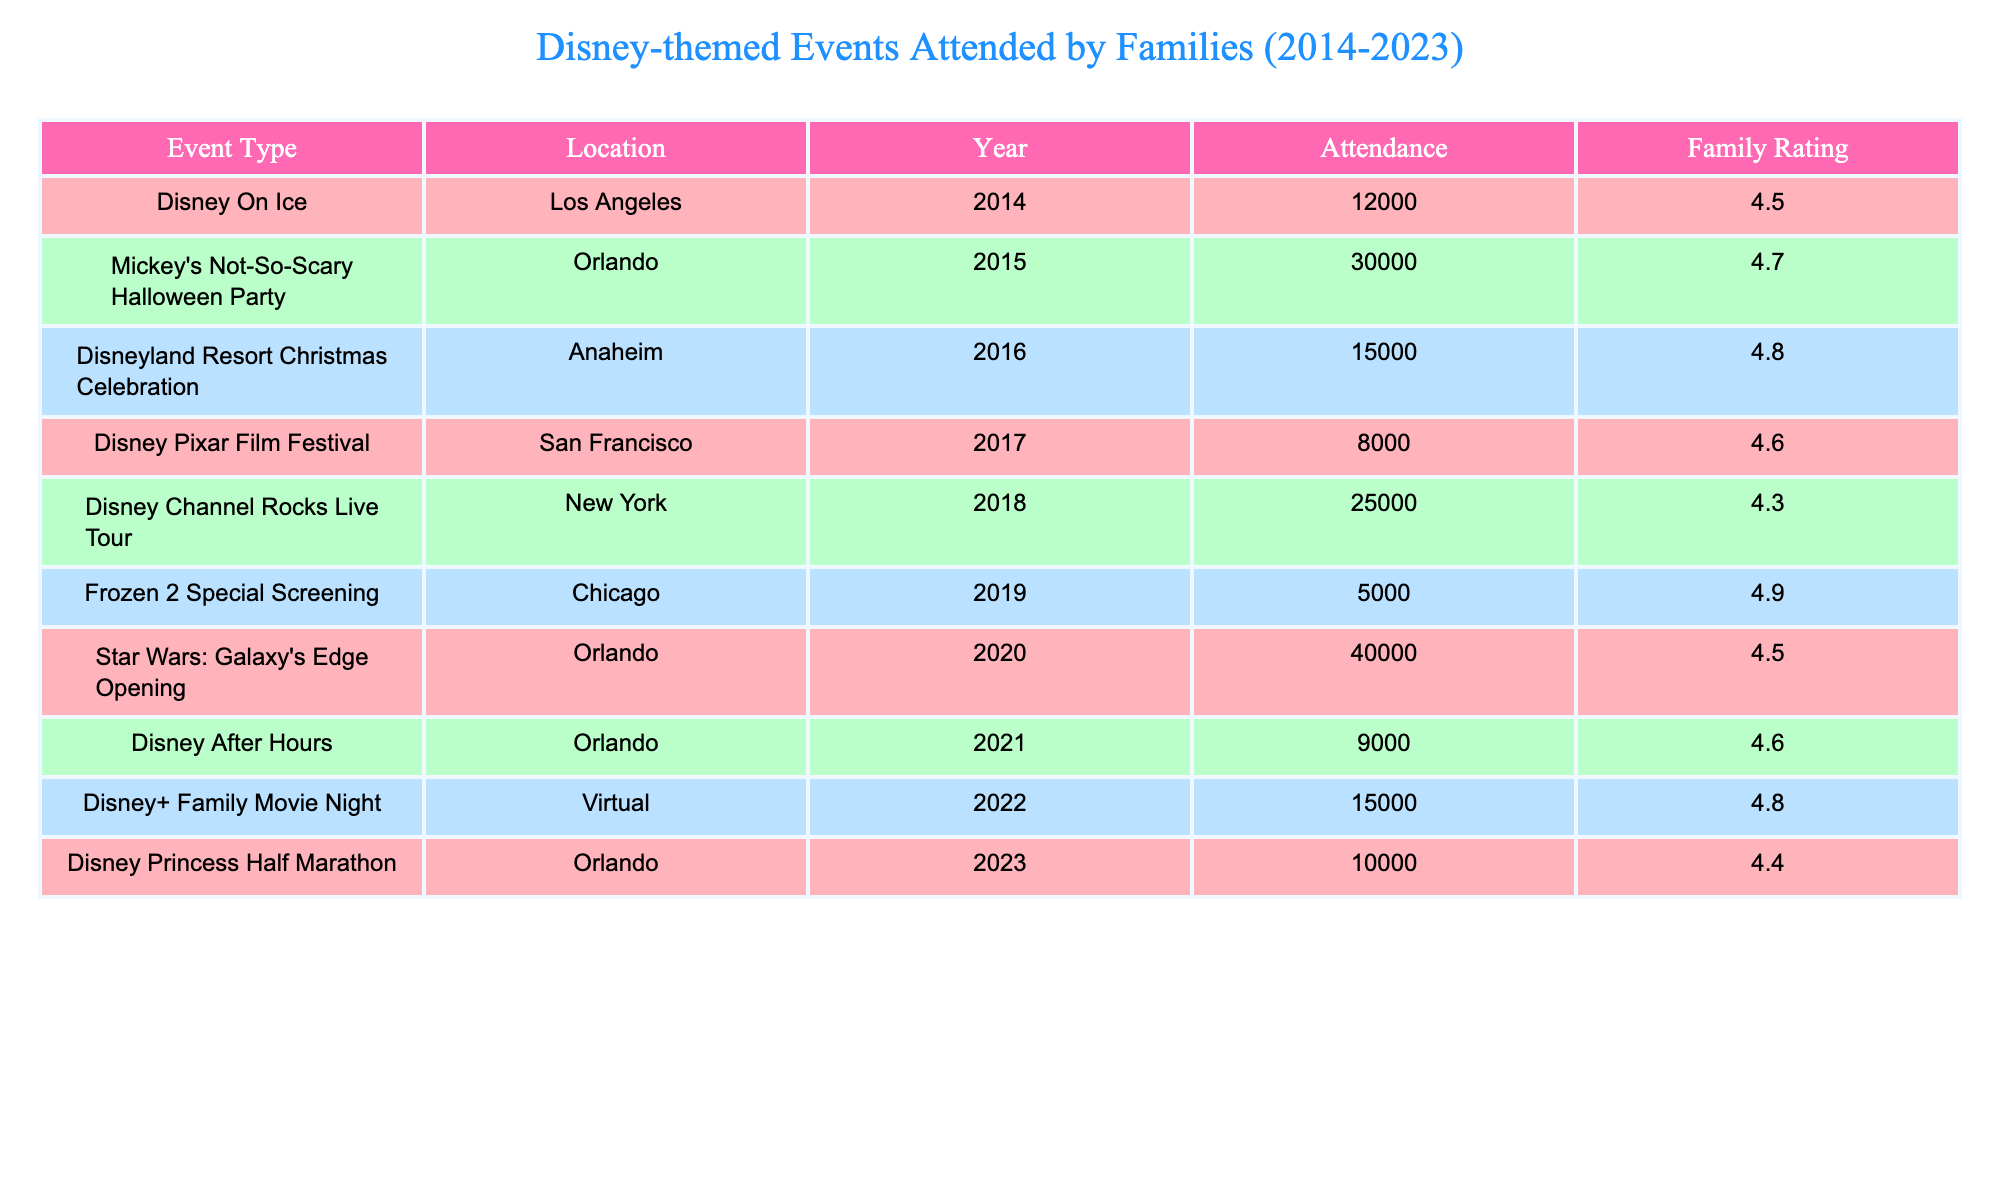What was the attendance at Mickey's Not-So-Scary Halloween Party? The table shows that Mickey's Not-So-Scary Halloween Party had an attendance of 30,000 in 2015.
Answer: 30,000 Which event had the highest family rating? Looking at the family ratings in the table, Frozen 2 Special Screening has the highest rating of 4.9.
Answer: 4.9 How many events took place in Orlando? Counting the rows in the table, there are four events listed in Orlando: Mickey's Not-So-Scary Halloween Party, Star Wars: Galaxy's Edge Opening, Disney After Hours, and Disney Princess Half Marathon.
Answer: 4 What is the average attendance for events held in 2022 and 2023? The attendance for 2022 (Disney+ Family Movie Night) is 15,000 and for 2023 (Disney Princess Half Marathon) is 10,000. Adding these together gives 15,000 + 10,000 = 25,000. Dividing by 2 (number of events) results in an average of 12,500.
Answer: 12,500 Was there any event in 2018 that had a family rating higher than 4.5? The only event in 2018 was the Disney Channel Rocks Live Tour, which has a family rating of 4.3, which is lower than 4.5. Therefore, the answer is no.
Answer: No What is the total attendance of all events held in 2020 and later? The events in 2020, 2021, 2022, and 2023 have attendances of 40,000, 9,000, 15,000, and 10,000 respectively. Summing these gives: 40,000 + 9,000 + 15,000 + 10,000 = 74,000.
Answer: 74,000 Did the attendance for the Disney Pixar Film Festival exceed 10,000? The attendance for the Disney Pixar Film Festival is noted as 8,000, which is less than 10,000. Thus, the answer is no.
Answer: No Which event had a lower family rating: Disney On Ice or Frozen 2 Special Screening? Disney On Ice has a family rating of 4.5, while Frozen 2 Special Screening has a rating of 4.9. Since 4.5 is less than 4.9, Disney On Ice has the lower rating.
Answer: Disney On Ice Based on attendance, which event was the least popular over the past decade? The table indicates that the event with the lowest attendance is the Frozen 2 Special Screening, with 5,000 attendees.
Answer: 5,000 What year had the event with the highest attendance? The event with the highest attendance, Star Wars: Galaxy's Edge Opening, occurred in 2020, with an attendance of 40,000.
Answer: 2020 